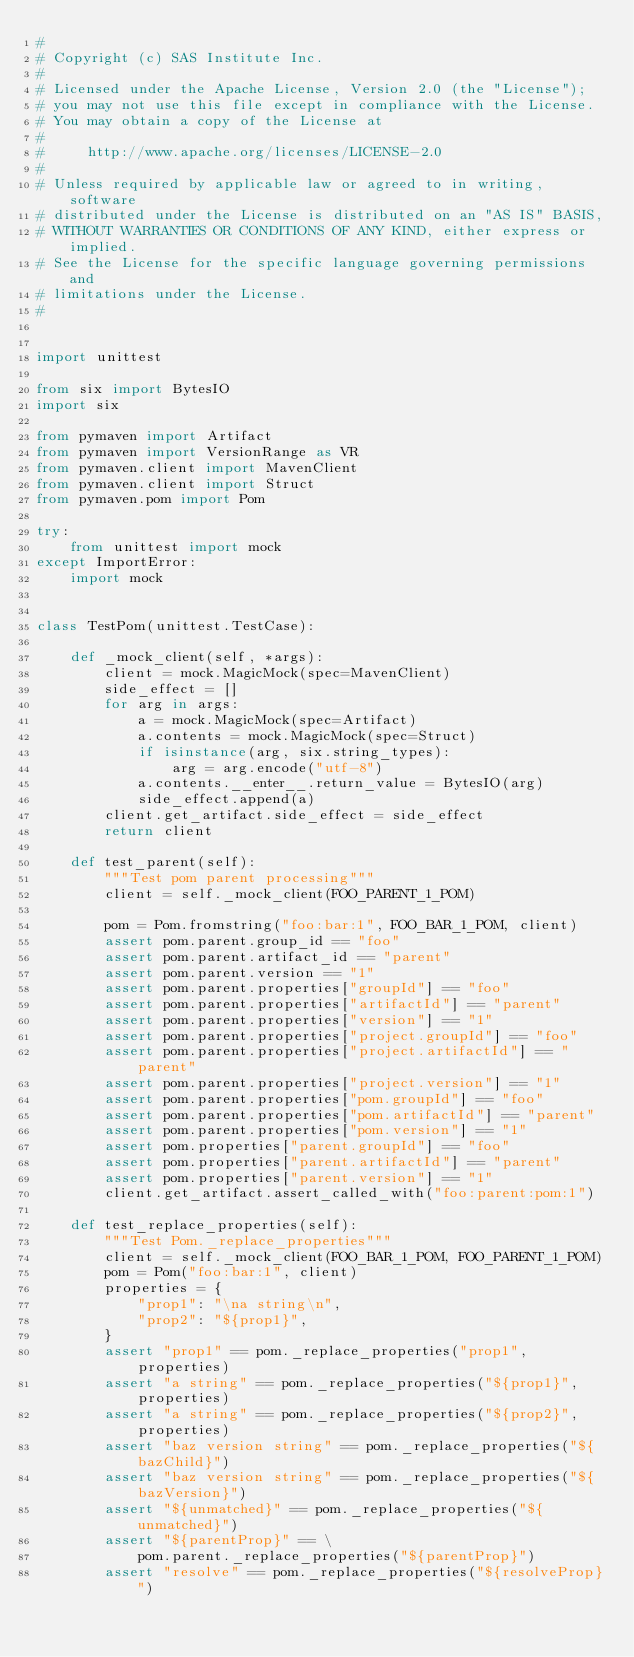Convert code to text. <code><loc_0><loc_0><loc_500><loc_500><_Python_>#
# Copyright (c) SAS Institute Inc.
#
# Licensed under the Apache License, Version 2.0 (the "License");
# you may not use this file except in compliance with the License.
# You may obtain a copy of the License at
#
#     http://www.apache.org/licenses/LICENSE-2.0
#
# Unless required by applicable law or agreed to in writing, software
# distributed under the License is distributed on an "AS IS" BASIS,
# WITHOUT WARRANTIES OR CONDITIONS OF ANY KIND, either express or implied.
# See the License for the specific language governing permissions and
# limitations under the License.
#


import unittest

from six import BytesIO
import six

from pymaven import Artifact
from pymaven import VersionRange as VR
from pymaven.client import MavenClient
from pymaven.client import Struct
from pymaven.pom import Pom

try:
    from unittest import mock
except ImportError:
    import mock


class TestPom(unittest.TestCase):

    def _mock_client(self, *args):
        client = mock.MagicMock(spec=MavenClient)
        side_effect = []
        for arg in args:
            a = mock.MagicMock(spec=Artifact)
            a.contents = mock.MagicMock(spec=Struct)
            if isinstance(arg, six.string_types):
                arg = arg.encode("utf-8")
            a.contents.__enter__.return_value = BytesIO(arg)
            side_effect.append(a)
        client.get_artifact.side_effect = side_effect
        return client

    def test_parent(self):
        """Test pom parent processing"""
        client = self._mock_client(FOO_PARENT_1_POM)

        pom = Pom.fromstring("foo:bar:1", FOO_BAR_1_POM, client)
        assert pom.parent.group_id == "foo"
        assert pom.parent.artifact_id == "parent"
        assert pom.parent.version == "1"
        assert pom.parent.properties["groupId"] == "foo"
        assert pom.parent.properties["artifactId"] == "parent"
        assert pom.parent.properties["version"] == "1"
        assert pom.parent.properties["project.groupId"] == "foo"
        assert pom.parent.properties["project.artifactId"] == "parent"
        assert pom.parent.properties["project.version"] == "1"
        assert pom.parent.properties["pom.groupId"] == "foo"
        assert pom.parent.properties["pom.artifactId"] == "parent"
        assert pom.parent.properties["pom.version"] == "1"
        assert pom.properties["parent.groupId"] == "foo"
        assert pom.properties["parent.artifactId"] == "parent"
        assert pom.properties["parent.version"] == "1"
        client.get_artifact.assert_called_with("foo:parent:pom:1")

    def test_replace_properties(self):
        """Test Pom._replace_properties"""
        client = self._mock_client(FOO_BAR_1_POM, FOO_PARENT_1_POM)
        pom = Pom("foo:bar:1", client)
        properties = {
            "prop1": "\na string\n",
            "prop2": "${prop1}",
        }
        assert "prop1" == pom._replace_properties("prop1", properties)
        assert "a string" == pom._replace_properties("${prop1}", properties)
        assert "a string" == pom._replace_properties("${prop2}", properties)
        assert "baz version string" == pom._replace_properties("${bazChild}")
        assert "baz version string" == pom._replace_properties("${bazVersion}")
        assert "${unmatched}" == pom._replace_properties("${unmatched}")
        assert "${parentProp}" == \
            pom.parent._replace_properties("${parentProp}")
        assert "resolve" == pom._replace_properties("${resolveProp}")</code> 